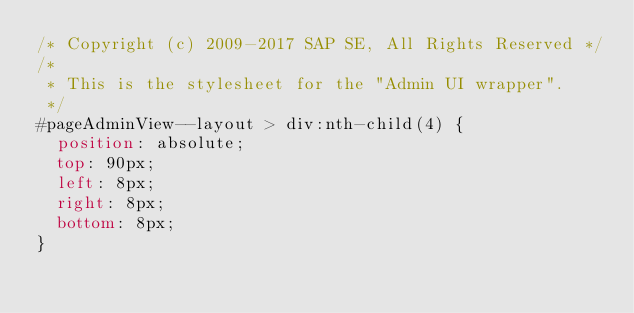<code> <loc_0><loc_0><loc_500><loc_500><_CSS_>/* Copyright (c) 2009-2017 SAP SE, All Rights Reserved */
/*
 * This is the stylesheet for the "Admin UI wrapper".
 */
#pageAdminView--layout > div:nth-child(4) {
  position: absolute;
  top: 90px;
  left: 8px;
  right: 8px;
  bottom: 8px;
}
</code> 